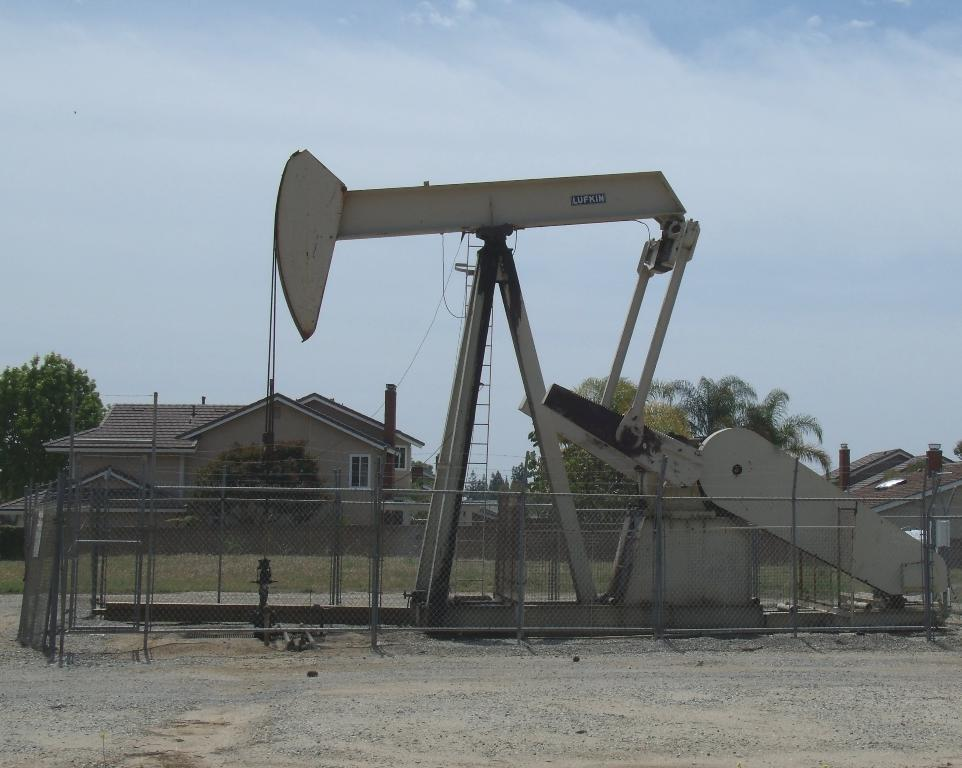What type of machine is present in the image? There is a white color machine in the image that resembles a crane. What can be seen in the foreground of the image? There is a fence in the image. What is visible in the background of the image? There are trees, a house, and the sky visible in the background of the image. What type of advertisement can be seen on the doll in the image? There is no doll present in the image, so there cannot be an advertisement on it. 